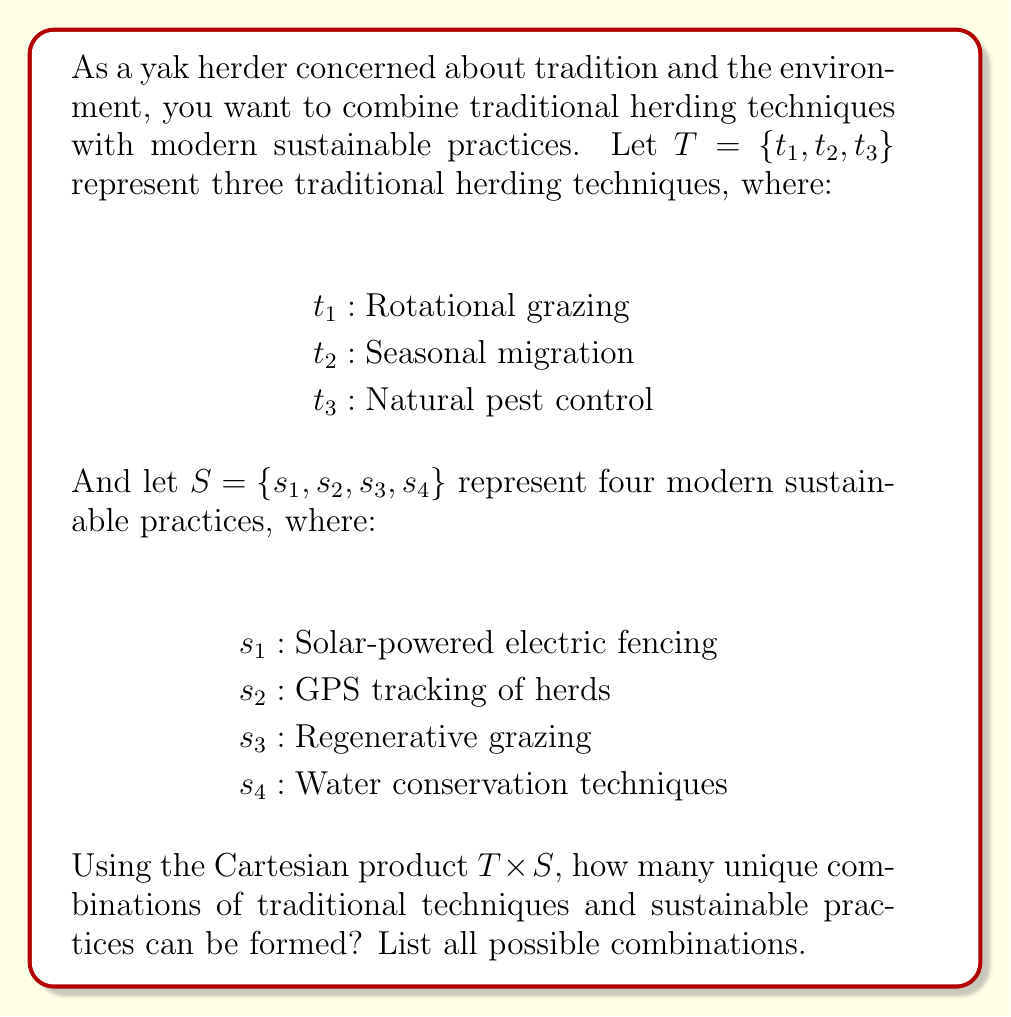Give your solution to this math problem. To solve this problem, we need to understand the concept of Cartesian product and apply it to the given sets.

1. The Cartesian product of two sets $A$ and $B$, denoted as $A \times B$, is the set of all ordered pairs $(a,b)$ where $a \in A$ and $b \in B$.

2. In this case, we have:
   $T = \{t_1, t_2, t_3\}$
   $S = \{s_1, s_2, s_3, s_4\}$

3. To find $T \times S$, we pair each element of $T$ with each element of $S$:

   $T \times S = \{(t_1,s_1), (t_1,s_2), (t_1,s_3), (t_1,s_4),$ 
                $(t_2,s_1), (t_2,s_2), (t_2,s_3), (t_2,s_4),$
                $(t_3,s_1), (t_3,s_2), (t_3,s_3), (t_3,s_4)\}$

4. To count the number of elements in $T \times S$, we can use the multiplication principle:
   $|T \times S| = |T| \cdot |S| = 3 \cdot 4 = 12$

Therefore, there are 12 unique combinations of traditional techniques and sustainable practices.

The list of all possible combinations is:
1. $(t_1,s_1)$: Rotational grazing with solar-powered electric fencing
2. $(t_1,s_2)$: Rotational grazing with GPS tracking of herds
3. $(t_1,s_3)$: Rotational grazing with regenerative grazing
4. $(t_1,s_4)$: Rotational grazing with water conservation techniques
5. $(t_2,s_1)$: Seasonal migration with solar-powered electric fencing
6. $(t_2,s_2)$: Seasonal migration with GPS tracking of herds
7. $(t_2,s_3)$: Seasonal migration with regenerative grazing
8. $(t_2,s_4)$: Seasonal migration with water conservation techniques
9. $(t_3,s_1)$: Natural pest control with solar-powered electric fencing
10. $(t_3,s_2)$: Natural pest control with GPS tracking of herds
11. $(t_3,s_3)$: Natural pest control with regenerative grazing
12. $(t_3,s_4)$: Natural pest control with water conservation techniques
Answer: There are 12 unique combinations of traditional techniques and sustainable practices. The Cartesian product $T \times S$ contains all these combinations:

$T \times S = \{(t_1,s_1), (t_1,s_2), (t_1,s_3), (t_1,s_4), (t_2,s_1), (t_2,s_2), (t_2,s_3), (t_2,s_4), (t_3,s_1), (t_3,s_2), (t_3,s_3), (t_3,s_4)\}$ 